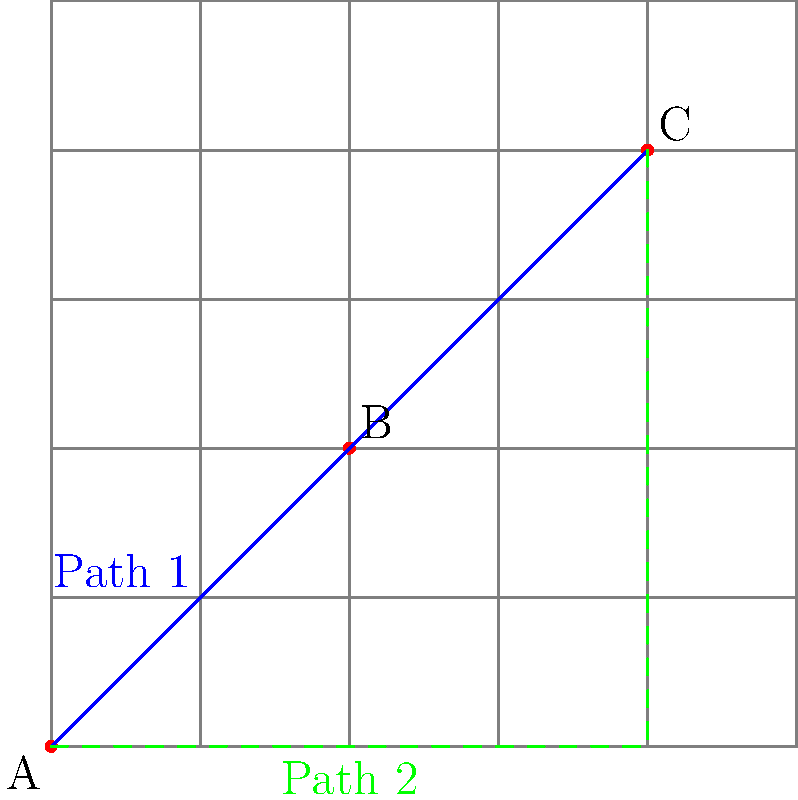In a 2D grid network, three nodes A, B, and C are located at coordinates (0,0), (2,2), and (4,4) respectively. Two possible paths between A and C are shown: Path 1 (solid blue) goes through B, while Path 2 (dashed green) follows the grid edges. Which path is shorter, and by how much? Assume each grid unit represents 1 km. To solve this problem, we need to calculate the lengths of both paths and compare them:

1. Path 1 (through B):
   - Length AB = $\sqrt{(2-0)^2 + (2-0)^2} = \sqrt{8} = 2\sqrt{2}$ km
   - Length BC = $\sqrt{(4-2)^2 + (4-2)^2} = \sqrt{8} = 2\sqrt{2}$ km
   - Total length of Path 1 = $2\sqrt{2} + 2\sqrt{2} = 4\sqrt{2}$ km

2. Path 2 (along grid edges):
   - Horizontal distance = 4 km
   - Vertical distance = 4 km
   - Total length of Path 2 = 4 + 4 = 8 km

3. Difference in length:
   - Difference = Path 2 - Path 1
   - Difference = $8 - 4\sqrt{2}$ km
   - Difference ≈ 0.34 km (rounded to two decimal places)

Therefore, Path 1 (through B) is shorter than Path 2 by approximately 0.34 km.

This problem demonstrates the importance of optimizing network paths in IT infrastructure, as choosing the shortest route can lead to improved performance and reduced latency in data transmission.
Answer: Path 1 is shorter by $8 - 4\sqrt{2}$ km (≈0.34 km). 